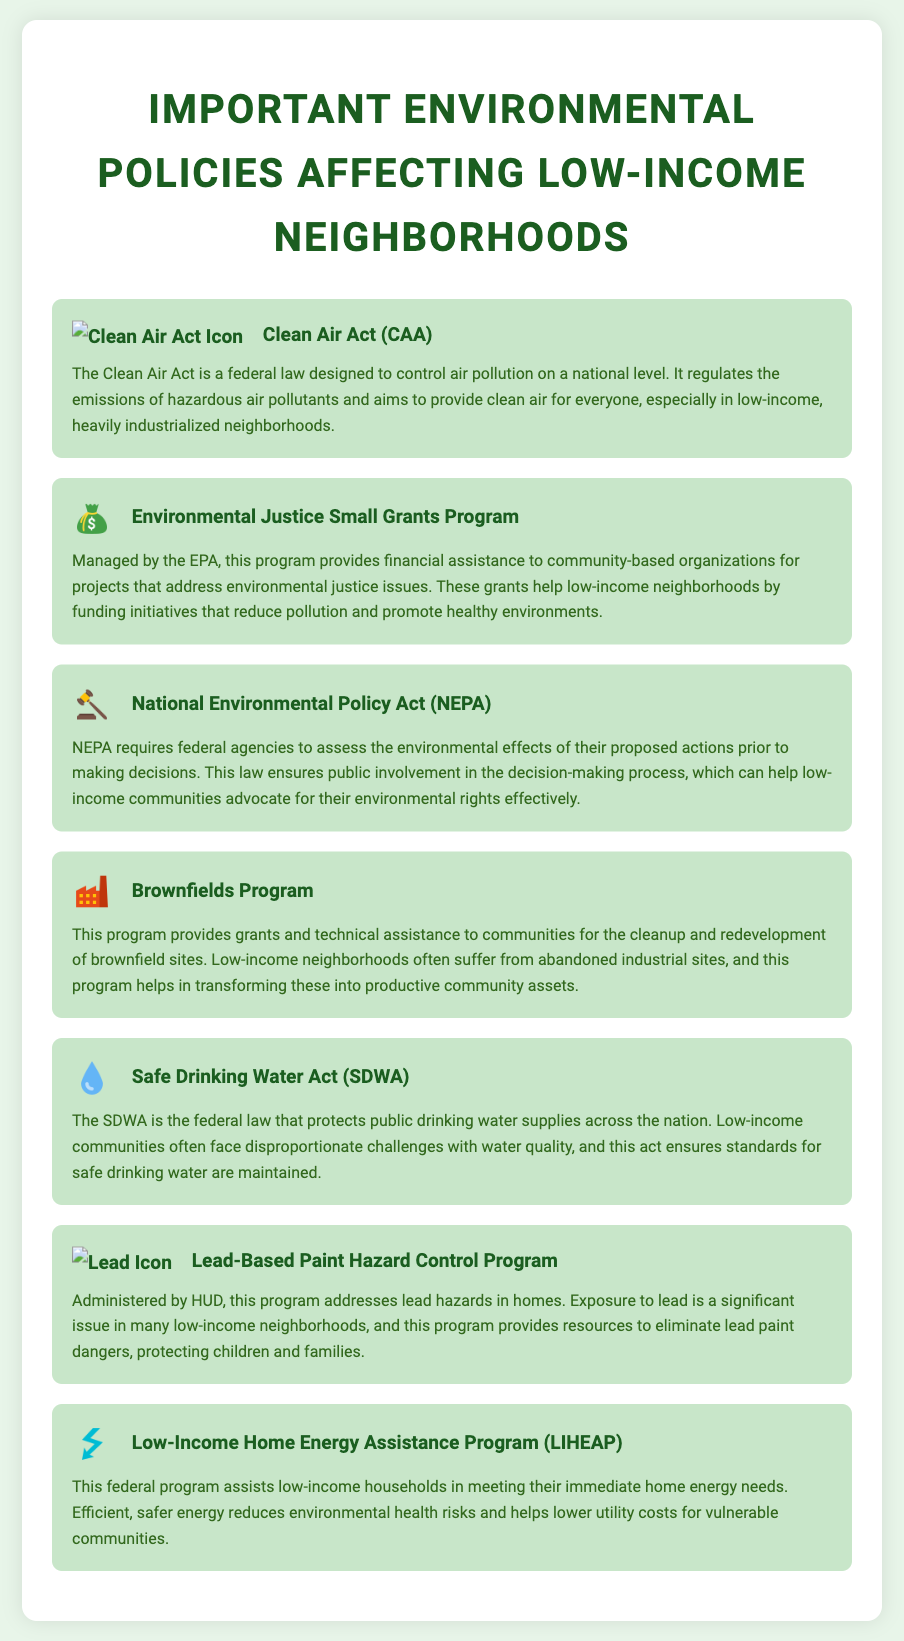What is the purpose of the Clean Air Act? The Clean Air Act is designed to control air pollution on a national level and aims to provide clean air for everyone, especially in low-income neighborhoods.
Answer: Control air pollution What federal program assists low-income households with energy needs? The Low-Income Home Energy Assistance Program (LIHEAP) assists low-income households in meeting their immediate home energy needs.
Answer: LIHEAP Which policy addresses lead hazards in homes? The Lead-Based Paint Hazard Control Program addresses lead hazards in homes, providing resources for their elimination.
Answer: Lead-Based Paint Hazard Control Program What type of assistance does the Environmental Justice Small Grants Program provide? The Environmental Justice Small Grants Program provides financial assistance to community-based organizations for projects addressing environmental justice issues.
Answer: Financial assistance How does NEPA benefit low-income communities? NEPA ensures public involvement in the decision-making process, allowing low-income communities to advocate for their environmental rights effectively.
Answer: Public involvement What is the significance of the Safe Drinking Water Act? The Safe Drinking Water Act protects public drinking water supplies and maintains standards for safe drinking water, crucial for low-income communities facing water quality challenges.
Answer: Protect public drinking water Which program helps with the cleanup of abandoned industrial sites? The Brownfields Program provides grants and assistance for the cleanup and redevelopment of brownfield sites in communities.
Answer: Brownfields Program What does the Safe Drinking Water Act aim to address specifically? The Safe Drinking Water Act aims to address the quality of public drinking water supplies across the nation.
Answer: Quality of water What kind of projects does the Environmental Justice Small Grants Program fund? The program funds projects that reduce pollution and promote healthy environments in low-income neighborhoods.
Answer: Reduce pollution and promote healthy environments 